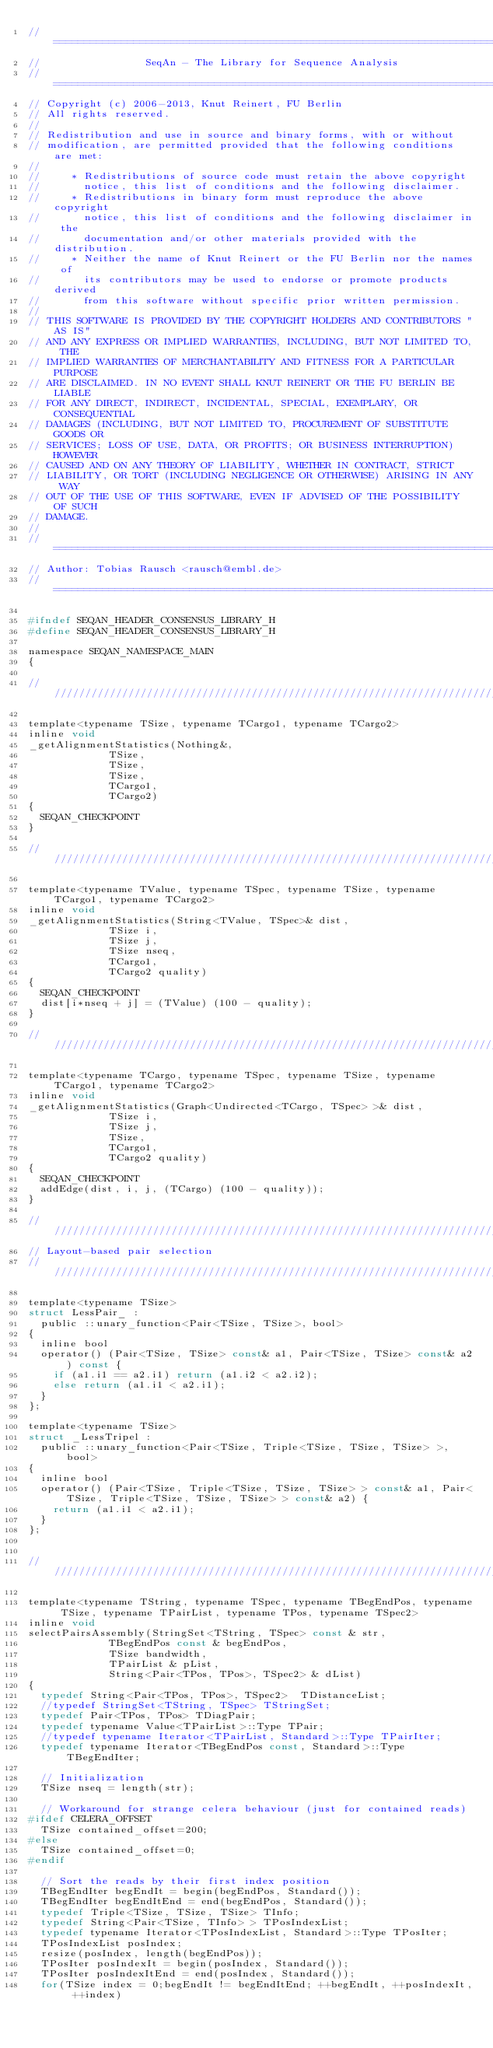Convert code to text. <code><loc_0><loc_0><loc_500><loc_500><_C_>// ==========================================================================
//                 SeqAn - The Library for Sequence Analysis
// ==========================================================================
// Copyright (c) 2006-2013, Knut Reinert, FU Berlin
// All rights reserved.
//
// Redistribution and use in source and binary forms, with or without
// modification, are permitted provided that the following conditions are met:
//
//     * Redistributions of source code must retain the above copyright
//       notice, this list of conditions and the following disclaimer.
//     * Redistributions in binary form must reproduce the above copyright
//       notice, this list of conditions and the following disclaimer in the
//       documentation and/or other materials provided with the distribution.
//     * Neither the name of Knut Reinert or the FU Berlin nor the names of
//       its contributors may be used to endorse or promote products derived
//       from this software without specific prior written permission.
//
// THIS SOFTWARE IS PROVIDED BY THE COPYRIGHT HOLDERS AND CONTRIBUTORS "AS IS"
// AND ANY EXPRESS OR IMPLIED WARRANTIES, INCLUDING, BUT NOT LIMITED TO, THE
// IMPLIED WARRANTIES OF MERCHANTABILITY AND FITNESS FOR A PARTICULAR PURPOSE
// ARE DISCLAIMED. IN NO EVENT SHALL KNUT REINERT OR THE FU BERLIN BE LIABLE
// FOR ANY DIRECT, INDIRECT, INCIDENTAL, SPECIAL, EXEMPLARY, OR CONSEQUENTIAL
// DAMAGES (INCLUDING, BUT NOT LIMITED TO, PROCUREMENT OF SUBSTITUTE GOODS OR
// SERVICES; LOSS OF USE, DATA, OR PROFITS; OR BUSINESS INTERRUPTION) HOWEVER
// CAUSED AND ON ANY THEORY OF LIABILITY, WHETHER IN CONTRACT, STRICT
// LIABILITY, OR TORT (INCLUDING NEGLIGENCE OR OTHERWISE) ARISING IN ANY WAY
// OUT OF THE USE OF THIS SOFTWARE, EVEN IF ADVISED OF THE POSSIBILITY OF SUCH
// DAMAGE.
//
// ==========================================================================
// Author: Tobias Rausch <rausch@embl.de>
// ==========================================================================

#ifndef SEQAN_HEADER_CONSENSUS_LIBRARY_H
#define SEQAN_HEADER_CONSENSUS_LIBRARY_H

namespace SEQAN_NAMESPACE_MAIN
{

//////////////////////////////////////////////////////////////////////////////

template<typename TSize, typename TCargo1, typename TCargo2>
inline void 
_getAlignmentStatistics(Nothing&,
						 TSize,
						 TSize,
						 TSize,
						 TCargo1,
						 TCargo2)
{
	SEQAN_CHECKPOINT
}

//////////////////////////////////////////////////////////////////////////////

template<typename TValue, typename TSpec, typename TSize, typename TCargo1, typename TCargo2>
inline void 
_getAlignmentStatistics(String<TValue, TSpec>& dist,
						 TSize i,
						 TSize j,
						 TSize nseq,
						 TCargo1,
						 TCargo2 quality)
{
	SEQAN_CHECKPOINT
	dist[i*nseq + j] = (TValue) (100 - quality);
}

//////////////////////////////////////////////////////////////////////////////

template<typename TCargo, typename TSpec, typename TSize, typename TCargo1, typename TCargo2>
inline void 
_getAlignmentStatistics(Graph<Undirected<TCargo, TSpec> >& dist,
						 TSize i,
						 TSize j,
						 TSize,
						 TCargo1,
						 TCargo2 quality)
{
	SEQAN_CHECKPOINT
	addEdge(dist, i, j, (TCargo) (100 - quality));
}

//////////////////////////////////////////////////////////////////////////////
// Layout-based pair selection
//////////////////////////////////////////////////////////////////////////////

template<typename TSize>
struct LessPair_ :
	public ::unary_function<Pair<TSize, TSize>, bool>
{
	inline bool 
	operator() (Pair<TSize, TSize> const& a1, Pair<TSize, TSize> const& a2) const {
		if (a1.i1 == a2.i1) return (a1.i2 < a2.i2);
		else return (a1.i1 < a2.i1);
	}
};

template<typename TSize>
struct _LessTripel :
	public ::unary_function<Pair<TSize, Triple<TSize, TSize, TSize> >, bool>
{
	inline bool 
	operator() (Pair<TSize, Triple<TSize, TSize, TSize> > const& a1, Pair<TSize, Triple<TSize, TSize, TSize> > const& a2) {
		return (a1.i1 < a2.i1);
	}
};


//////////////////////////////////////////////////////////////////////////////

template<typename TString, typename TSpec, typename TBegEndPos, typename TSize, typename TPairList, typename TPos, typename TSpec2>
inline void
selectPairsAssembly(StringSet<TString, TSpec> const & str,
			       TBegEndPos const & begEndPos,
			       TSize bandwidth,
			       TPairList & pList,
			       String<Pair<TPos, TPos>, TSpec2> & dList)
{
	typedef String<Pair<TPos, TPos>, TSpec2>  TDistanceList;
	//typedef StringSet<TString, TSpec> TStringSet;
	typedef Pair<TPos, TPos> TDiagPair;
	typedef typename Value<TPairList>::Type TPair;
	//typedef typename Iterator<TPairList, Standard>::Type TPairIter;
	typedef typename Iterator<TBegEndPos const, Standard>::Type TBegEndIter;

	// Initialization
	TSize nseq = length(str);

	// Workaround for strange celera behaviour (just for contained reads)
#ifdef CELERA_OFFSET
	TSize contained_offset=200;
#else
	TSize contained_offset=0;
#endif
	
	// Sort the reads by their first index position
	TBegEndIter begEndIt = begin(begEndPos, Standard());
	TBegEndIter begEndItEnd = end(begEndPos, Standard());
	typedef Triple<TSize, TSize, TSize> TInfo;
	typedef String<Pair<TSize, TInfo> > TPosIndexList;
	typedef typename Iterator<TPosIndexList, Standard>::Type TPosIter;
	TPosIndexList posIndex;
	resize(posIndex, length(begEndPos));
	TPosIter posIndexIt = begin(posIndex, Standard());
	TPosIter posIndexItEnd = end(posIndex, Standard());
	for(TSize index = 0;begEndIt != begEndItEnd; ++begEndIt, ++posIndexIt, ++index) </code> 